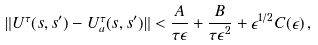<formula> <loc_0><loc_0><loc_500><loc_500>\| U ^ { \tau } ( s , s ^ { \prime } ) - U ^ { \tau } _ { a } ( s , s ^ { \prime } ) \| < \frac { A } { \tau \epsilon } + \frac { B } { \tau \epsilon ^ { 2 } } + \epsilon ^ { 1 / 2 } C ( \epsilon ) \, ,</formula> 